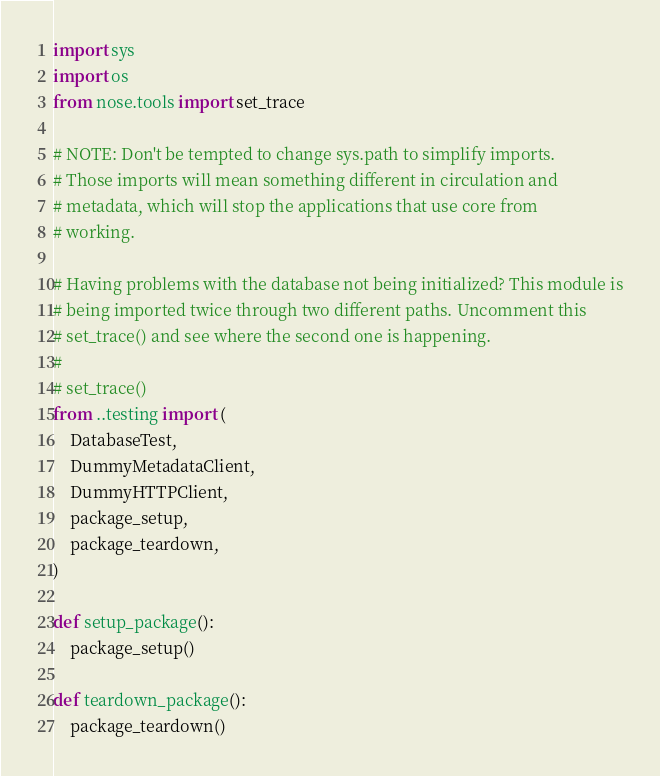Convert code to text. <code><loc_0><loc_0><loc_500><loc_500><_Python_>import sys
import os
from nose.tools import set_trace

# NOTE: Don't be tempted to change sys.path to simplify imports.
# Those imports will mean something different in circulation and
# metadata, which will stop the applications that use core from
# working.

# Having problems with the database not being initialized? This module is
# being imported twice through two different paths. Uncomment this
# set_trace() and see where the second one is happening.
#
# set_trace()
from ..testing import (
    DatabaseTest,
    DummyMetadataClient,
    DummyHTTPClient,
    package_setup,
    package_teardown,
)

def setup_package():
    package_setup()

def teardown_package():
    package_teardown()

</code> 